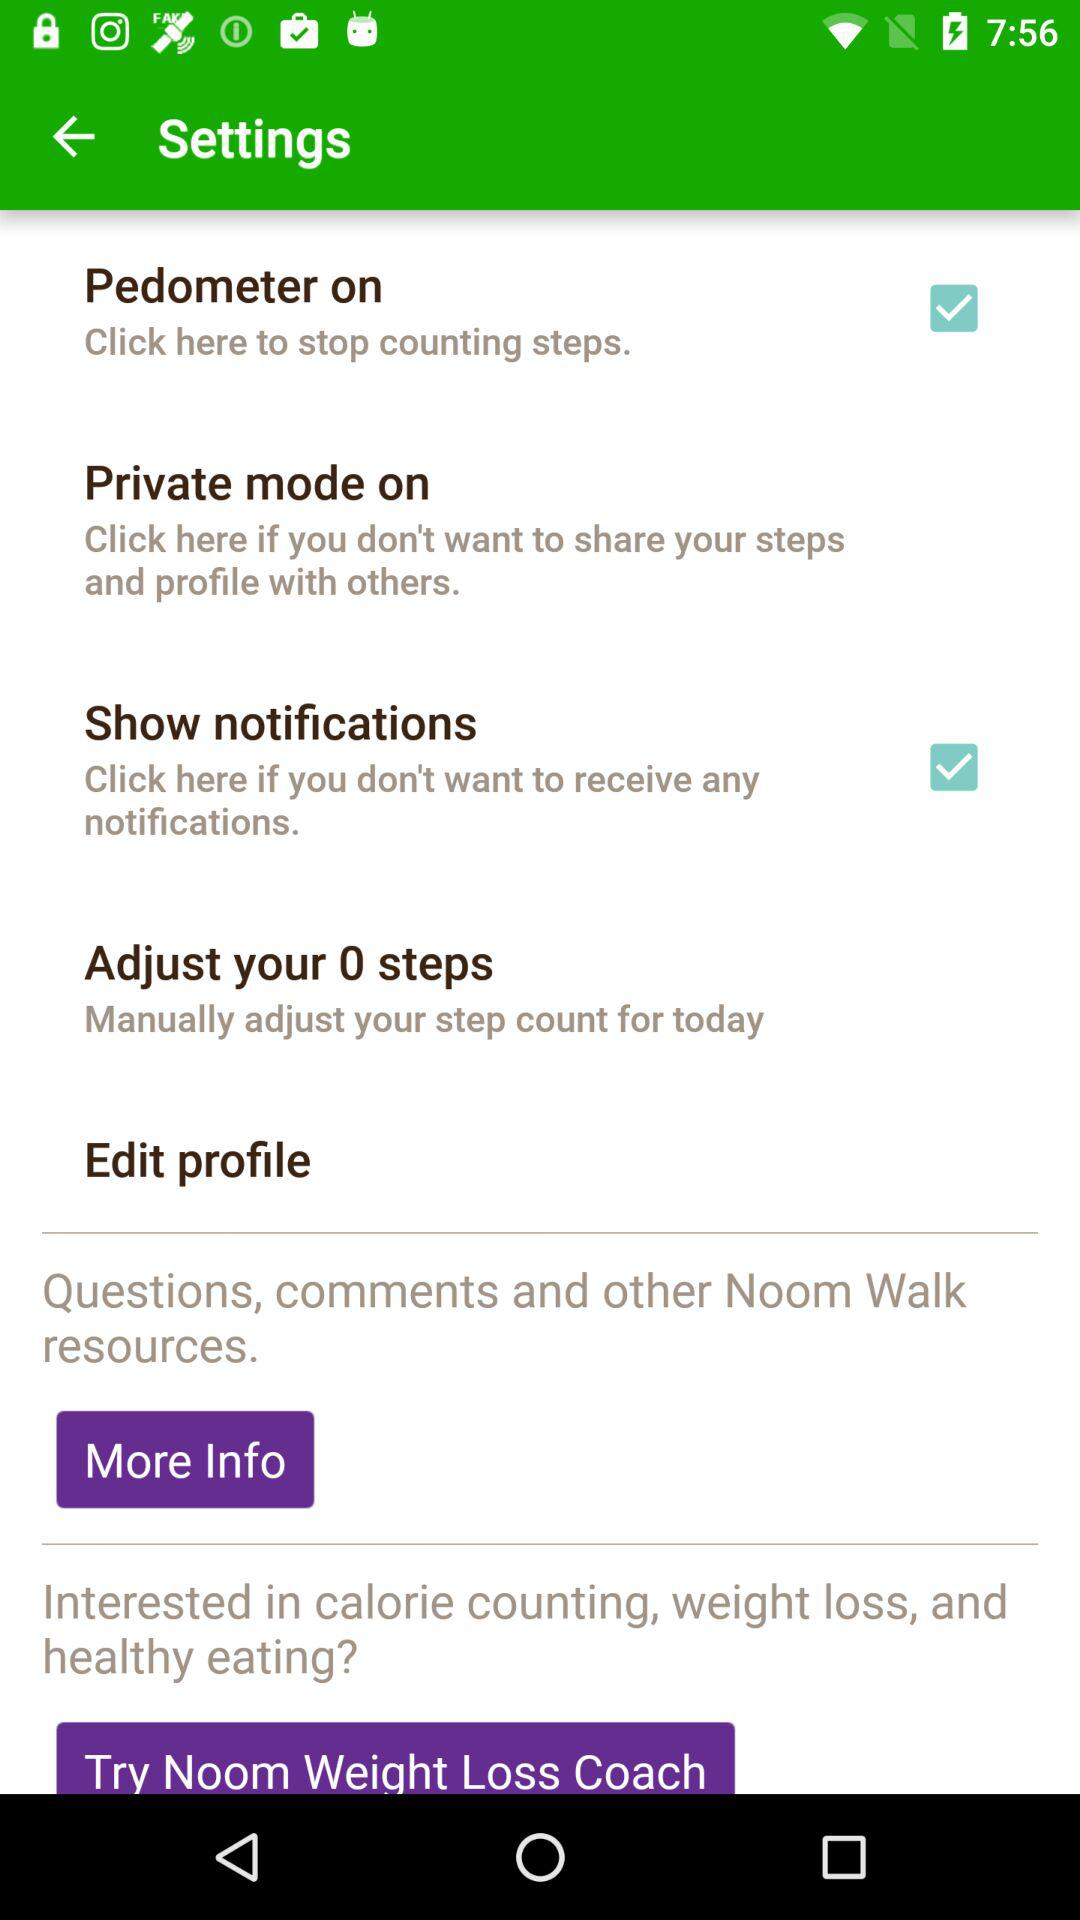Which settings are checked? The checked settings are "Pedometer on" and "Show notifications". 